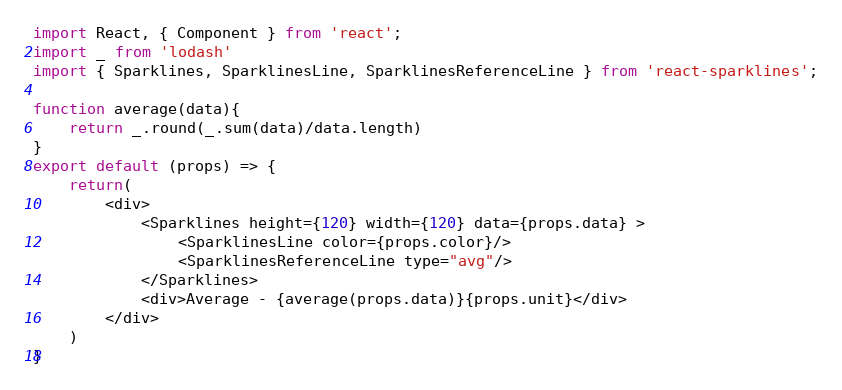Convert code to text. <code><loc_0><loc_0><loc_500><loc_500><_JavaScript_>import React, { Component } from 'react';
import _ from 'lodash'
import { Sparklines, SparklinesLine, SparklinesReferenceLine } from 'react-sparklines';

function average(data){
	return _.round(_.sum(data)/data.length)
}
export default (props) => {
	return(
		<div>
			<Sparklines height={120} width={120} data={props.data} >
				<SparklinesLine color={props.color}/>
				<SparklinesReferenceLine type="avg"/>
			</Sparklines>
			<div>Average - {average(props.data)}{props.unit}</div>
		</div>
	)
}</code> 